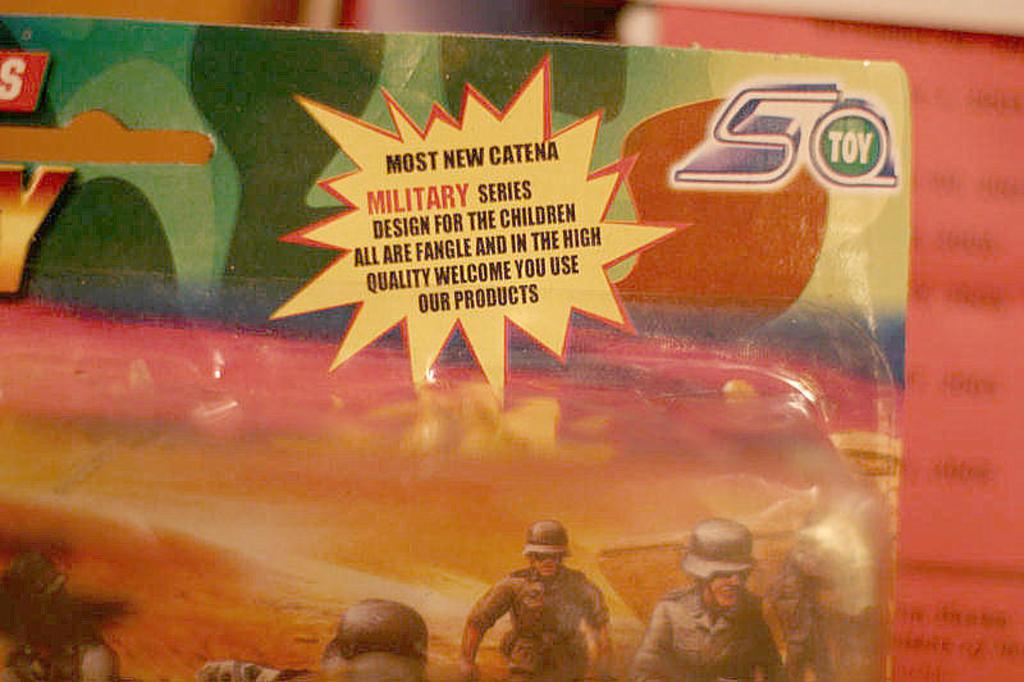What is present on the poster in the image? The poster contains pictures and text written on it. What can be found on the right side of the image? There is a book on the right side of the image. What is the book's primary feature? The book has text written on it. How does the brain balance the smoke in the image? There is no brain, smoke, or balance present in the image. 